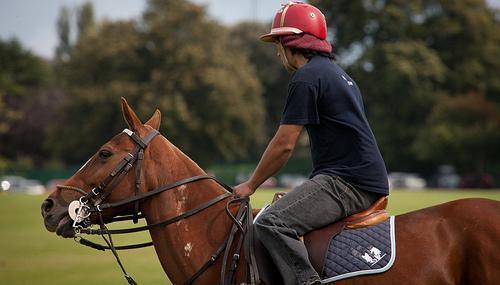How many horses are in the photo?
Give a very brief answer. 1. How many riders are on the horse?
Give a very brief answer. 1. 